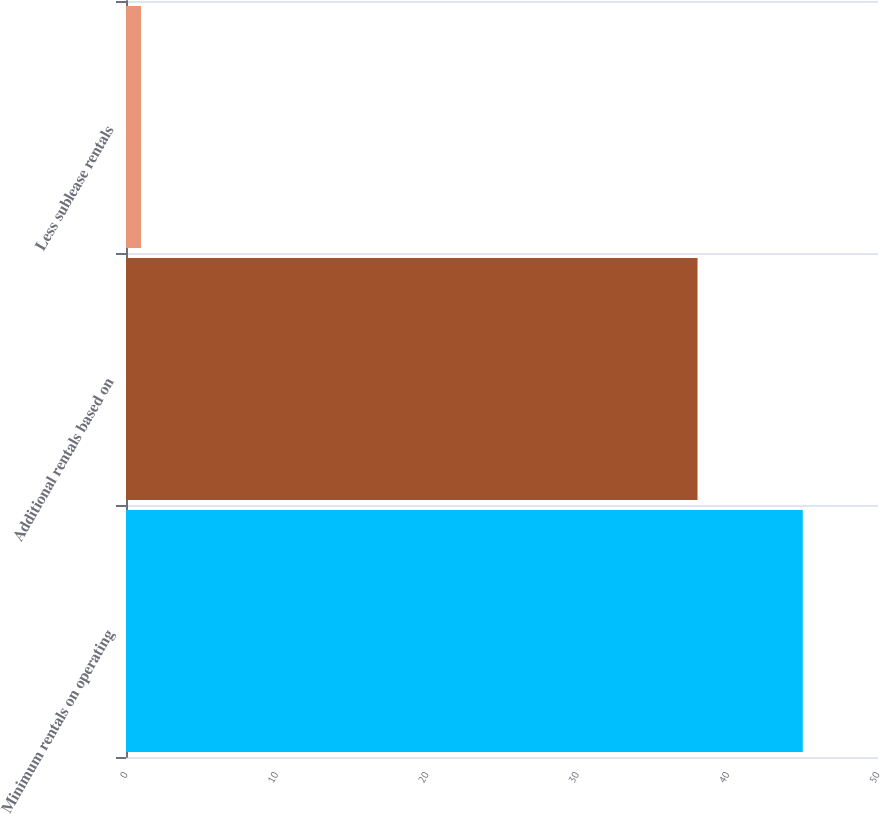Convert chart to OTSL. <chart><loc_0><loc_0><loc_500><loc_500><bar_chart><fcel>Minimum rentals on operating<fcel>Additional rentals based on<fcel>Less sublease rentals<nl><fcel>45<fcel>38<fcel>1<nl></chart> 